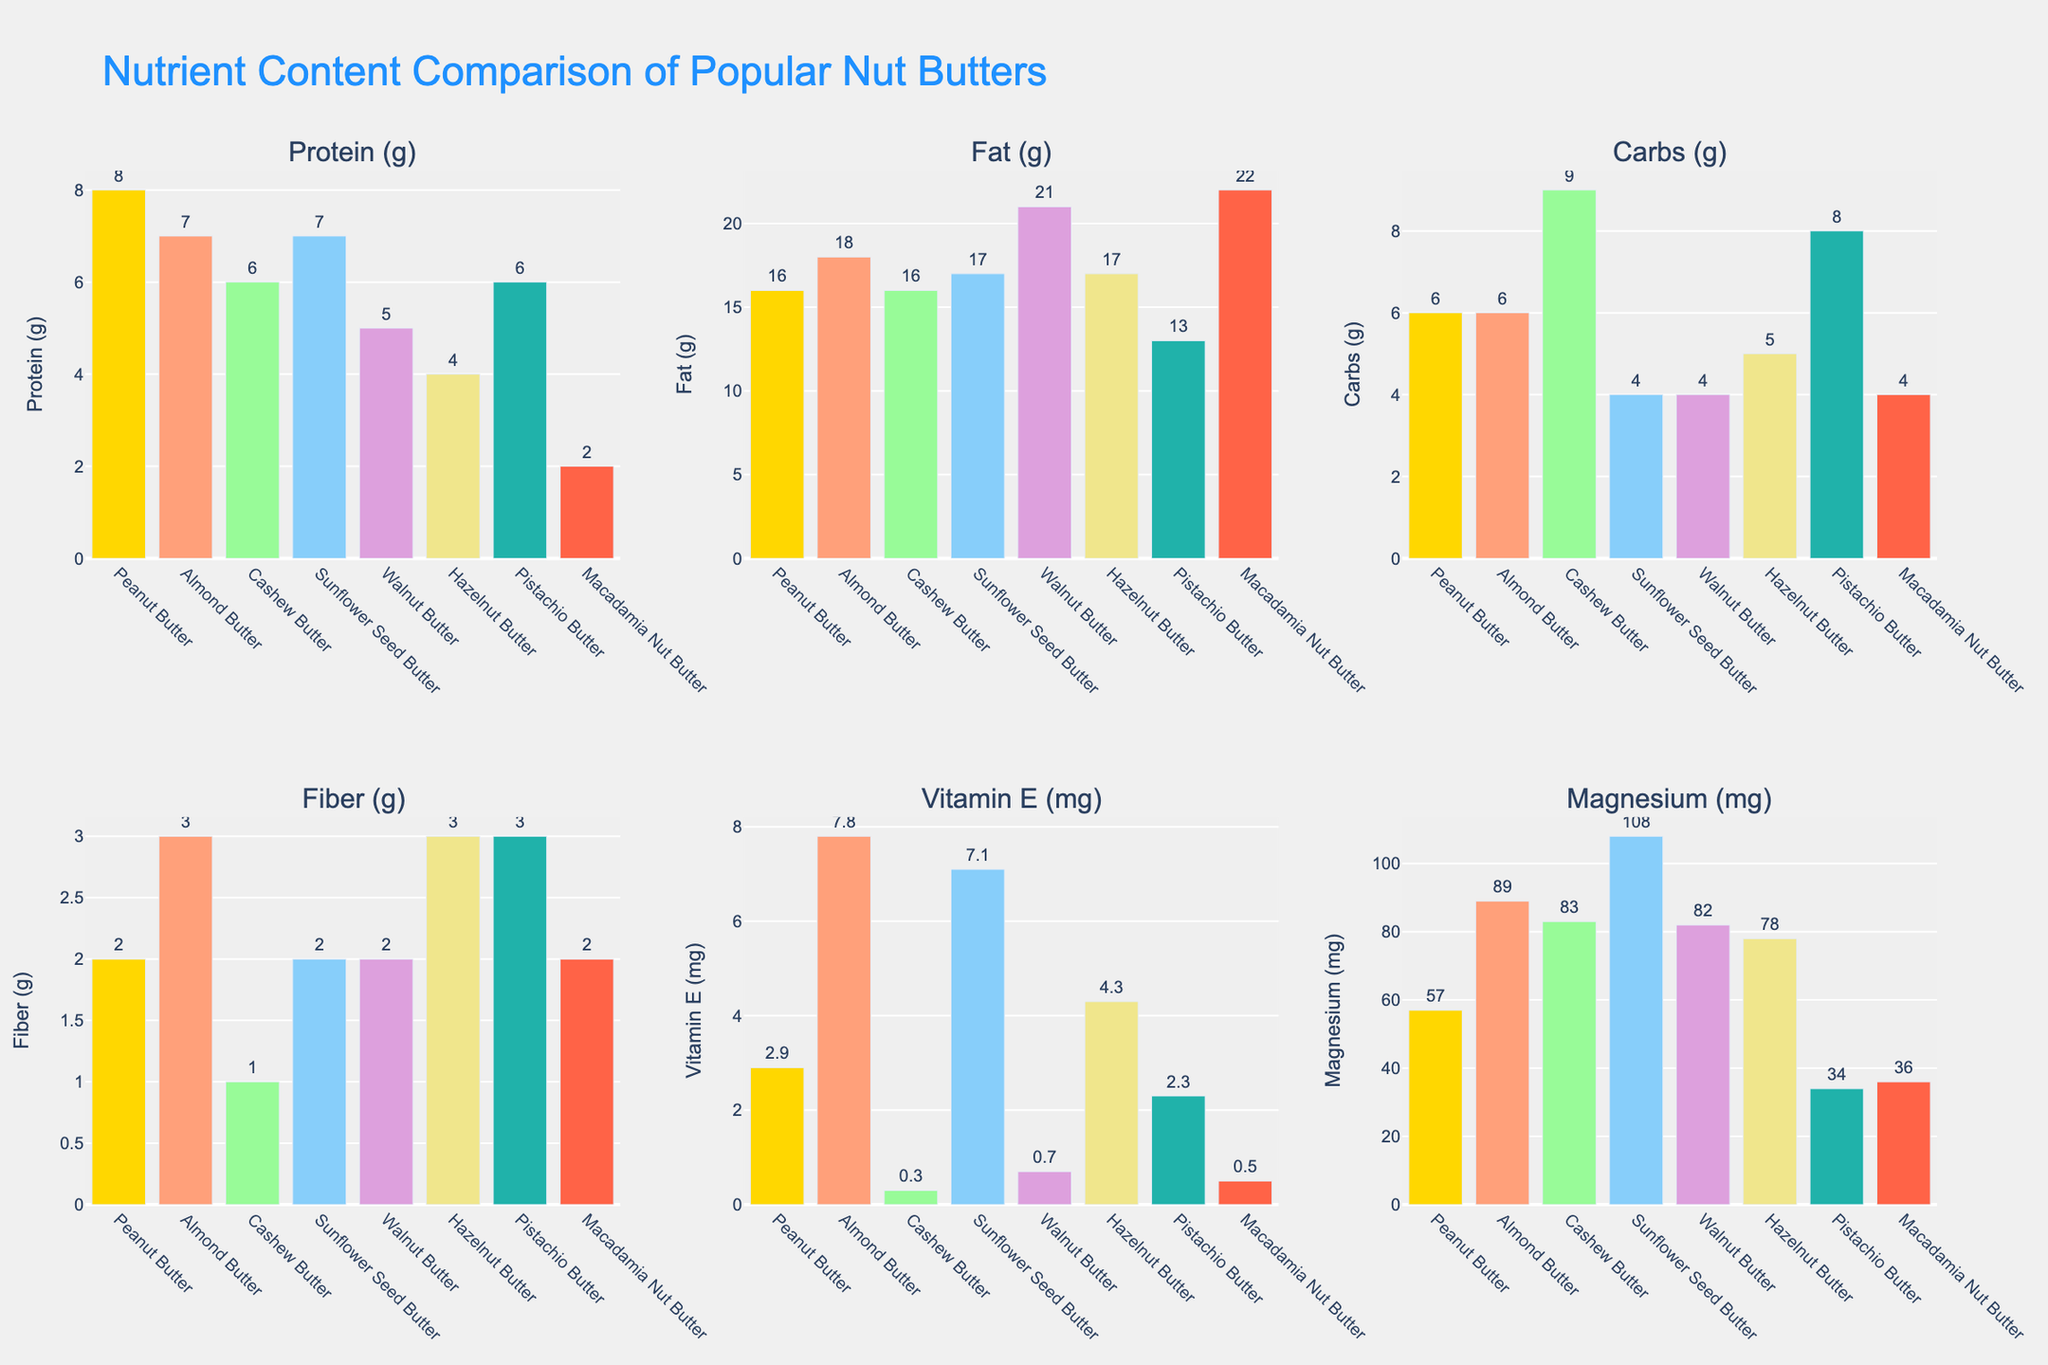Which nut butter has the highest protein content? By looking at the subplot for protein content, observe the height of each bar in the bar chart. Almond Butter and Sunflower Seed Butter both have the highest bars, indicating they have 7 grams of protein each.
Answer: Almond Butter, Sunflower Seed Butter Which nut butter contains the least fiber? Examine the fiber content subplot and compare the heights of the bars. Cashew Butter has the shortest bar, with 1 gram of fiber.
Answer: Cashew Butter How does the carb content of peanut butter compare to that of cashew butter? Look at the subplot for carbs and check the heights of the bars for both peanut butter and cashew butter. Peanut butter has a bar height corresponding to 6 grams, while cashew butter's bar height corresponds to 9 grams.
Answer: Peanut Butter has 3 grams less carbs than Cashew Butter Which nut butter has the highest magnesium content? In the magnesium content subplot, find the tallest bar. Sunflower Seed Butter has the tallest bar indicating 108 milligrams of magnesium.
Answer: Sunflower Seed Butter What is the difference in fat content between walnut butter and pistachio butter? Compare the height of the fat content bars for walnut butter (21 grams) and pistachio butter (13 grams). Subtracting these values gives the difference.
Answer: 8 grams Which nut butters have bars of equal height in the fiber content subplot? In the fiber content subplot, observe the bars for nut butters which have the same height. Almond Butter, Hazelnut Butter, and Pistachio Butter all have fiber content bars of 3 grams.
Answer: Almond Butter, Hazelnut Butter, Pistachio Butter What's the sum of the vitamin E content for peanut butter and sunflower seed butter? Locate the heights of the bars in the vitamin E subplot for peanut butter (2.9 mg) and sunflower seed butter (7.1 mg). Adding these values together gives the total vitamin E content.
Answer: 10 mg 